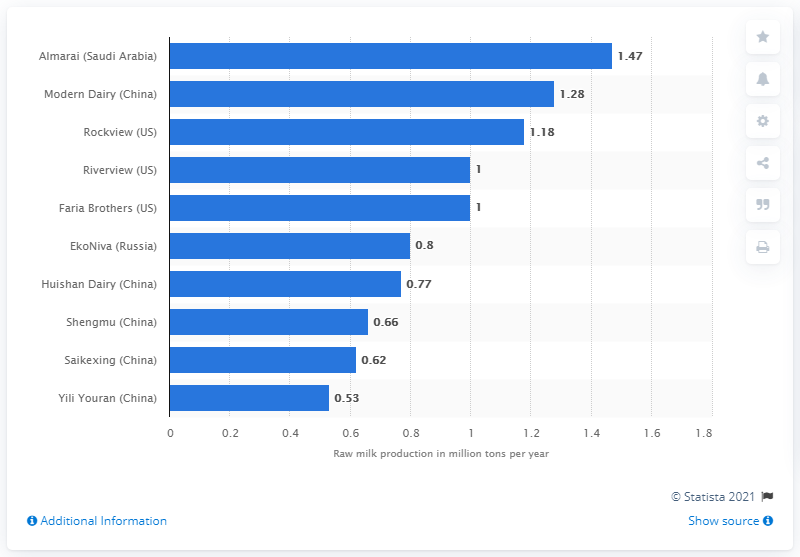Indicate a few pertinent items in this graphic. Rockview produced an average of 1.18 units of raw milk per year. 